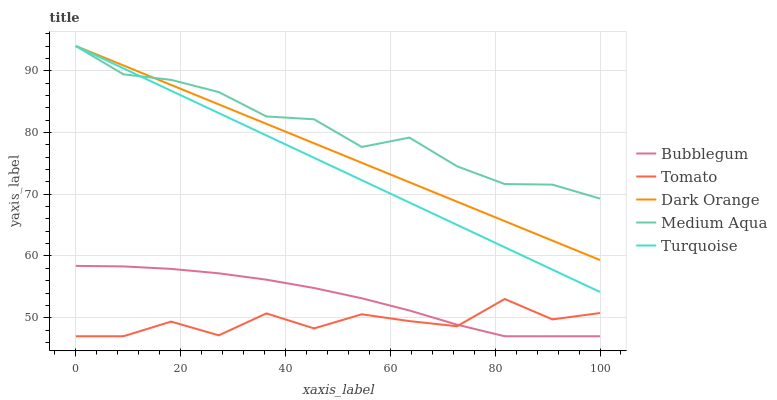Does Tomato have the minimum area under the curve?
Answer yes or no. Yes. Does Medium Aqua have the maximum area under the curve?
Answer yes or no. Yes. Does Dark Orange have the minimum area under the curve?
Answer yes or no. No. Does Dark Orange have the maximum area under the curve?
Answer yes or no. No. Is Dark Orange the smoothest?
Answer yes or no. Yes. Is Tomato the roughest?
Answer yes or no. Yes. Is Turquoise the smoothest?
Answer yes or no. No. Is Turquoise the roughest?
Answer yes or no. No. Does Tomato have the lowest value?
Answer yes or no. Yes. Does Dark Orange have the lowest value?
Answer yes or no. No. Does Medium Aqua have the highest value?
Answer yes or no. Yes. Does Bubblegum have the highest value?
Answer yes or no. No. Is Tomato less than Dark Orange?
Answer yes or no. Yes. Is Dark Orange greater than Bubblegum?
Answer yes or no. Yes. Does Bubblegum intersect Tomato?
Answer yes or no. Yes. Is Bubblegum less than Tomato?
Answer yes or no. No. Is Bubblegum greater than Tomato?
Answer yes or no. No. Does Tomato intersect Dark Orange?
Answer yes or no. No. 